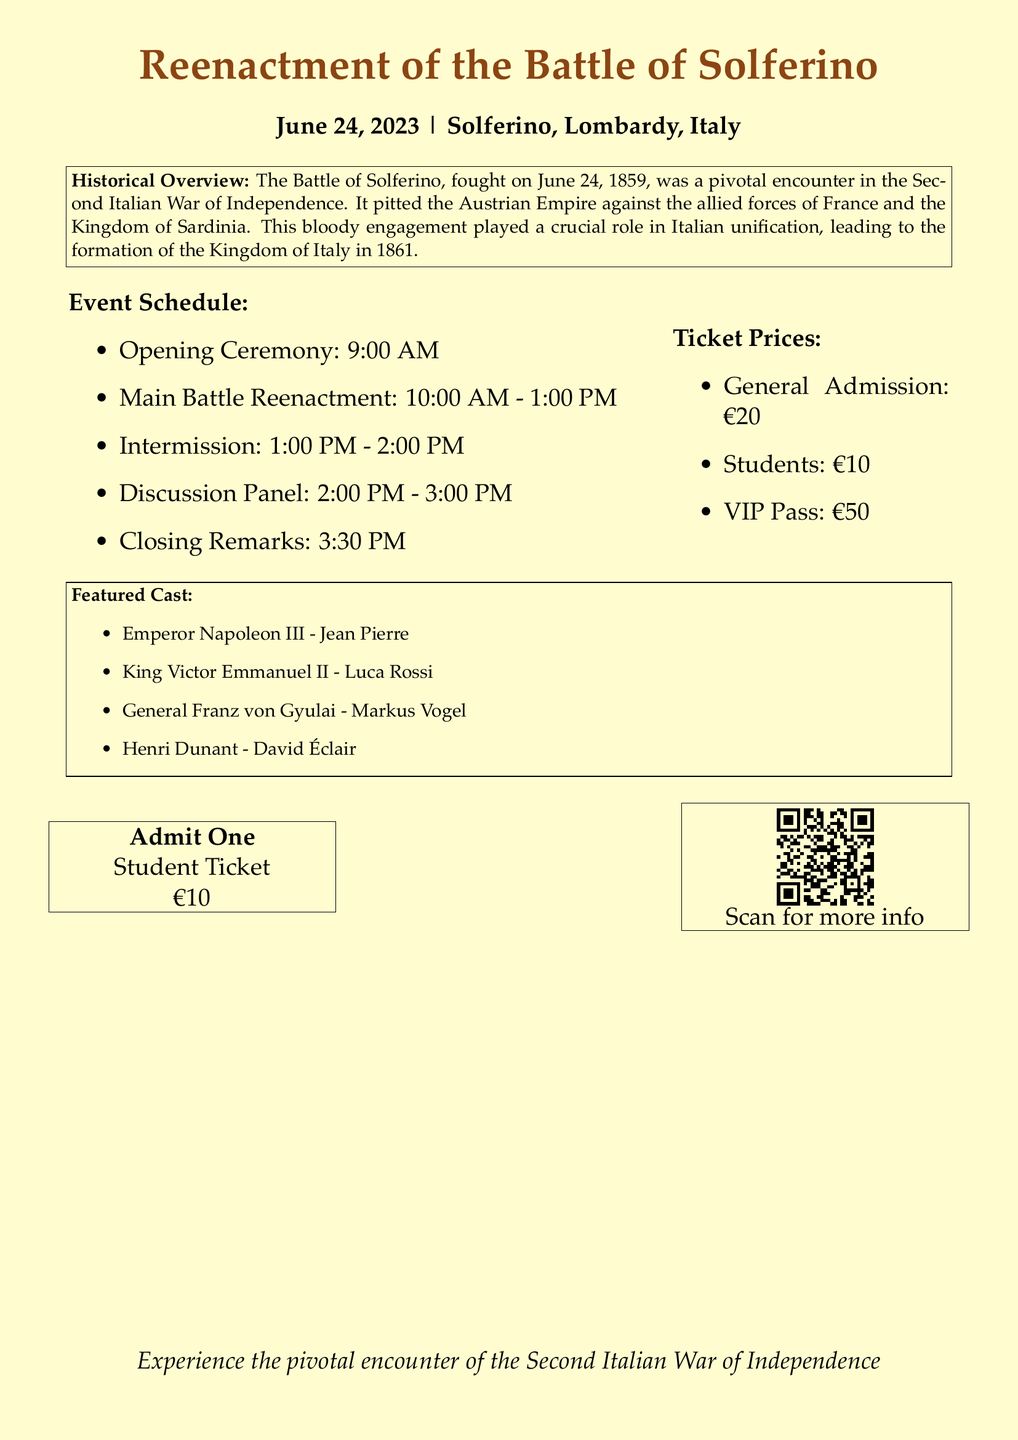What is the date of the event? The date of the event is provided in the document under the event title.
Answer: June 24, 2023 Who is portraying Emperor Napoleon III? The document lists the cast members and their roles, including who portrays Emperor Napoleon III.
Answer: Jean Pierre What is the ticket price for students? The document specifies different ticket prices, including the price for students.
Answer: €10 What time does the main battle reenactment start? The timing of the main battle reenactment is included in the event schedule section of the document.
Answer: 10:00 AM What was the pivotal encounter in the Second Italian War of Independence? The historical overview provides context about the battle within the framework of the war.
Answer: Battle of Solferino How many people are featured in the cast list? The cast list provided in the document mentions the number of featured members.
Answer: Four What type of event is being described? The document's title clearly indicates the nature of the event.
Answer: Reenactment What is the intermission duration? The event schedule outlines the duration of the intermission activity.
Answer: 1 hour 